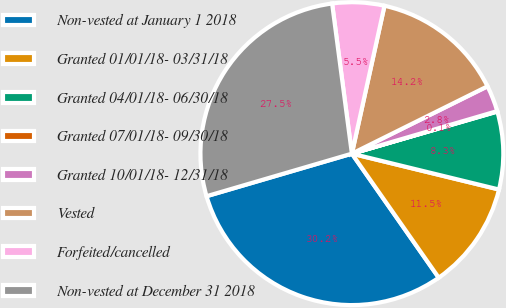Convert chart to OTSL. <chart><loc_0><loc_0><loc_500><loc_500><pie_chart><fcel>Non-vested at January 1 2018<fcel>Granted 01/01/18- 03/31/18<fcel>Granted 04/01/18- 06/30/18<fcel>Granted 07/01/18- 09/30/18<fcel>Granted 10/01/18- 12/31/18<fcel>Vested<fcel>Forfeited/cancelled<fcel>Non-vested at December 31 2018<nl><fcel>30.19%<fcel>11.47%<fcel>8.29%<fcel>0.05%<fcel>2.8%<fcel>14.21%<fcel>5.54%<fcel>27.45%<nl></chart> 